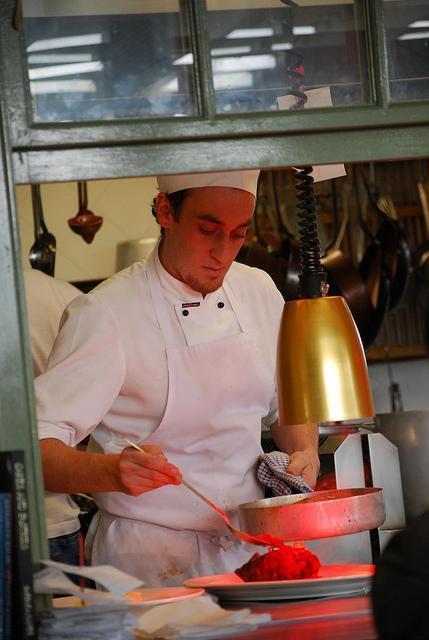How many people are there?
Give a very brief answer. 2. 